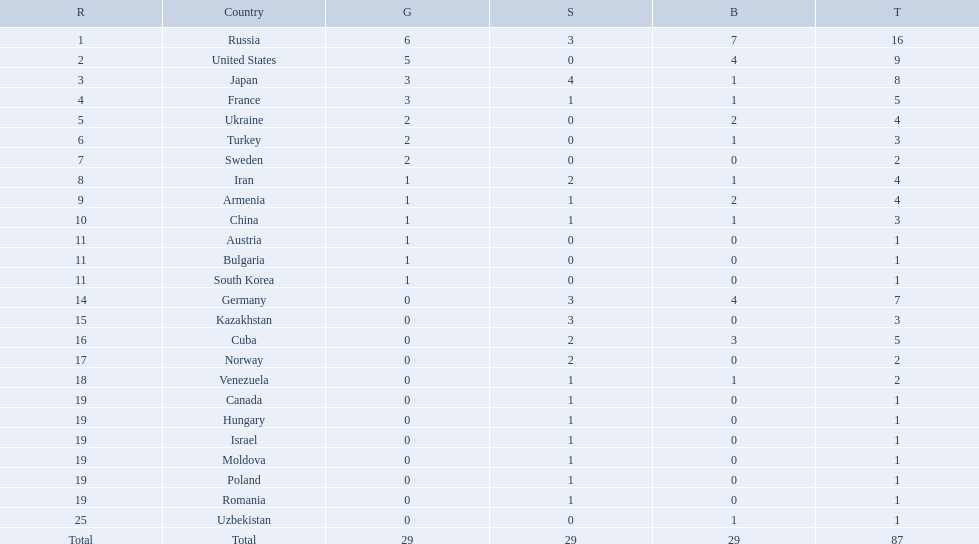What was iran's ranking? 8. What was germany's ranking? 14. Between iran and germany, which was not in the top 10? Germany. What were the nations that participated in the 1995 world wrestling championships? Russia, United States, Japan, France, Ukraine, Turkey, Sweden, Iran, Armenia, China, Austria, Bulgaria, South Korea, Germany, Kazakhstan, Cuba, Norway, Venezuela, Canada, Hungary, Israel, Moldova, Poland, Romania, Uzbekistan. How many gold medals did the united states earn in the championship? 5. What amount of medals earner was greater than this value? 6. What country earned these medals? Russia. Which countries competed in the 1995 world wrestling championships? Russia, United States, Japan, France, Ukraine, Turkey, Sweden, Iran, Armenia, China, Austria, Bulgaria, South Korea, Germany, Kazakhstan, Cuba, Norway, Venezuela, Canada, Hungary, Israel, Moldova, Poland, Romania, Uzbekistan. What country won only one medal? Austria, Bulgaria, South Korea, Canada, Hungary, Israel, Moldova, Poland, Romania, Uzbekistan. Which of these won a bronze medal? Uzbekistan. How many countries competed? Israel. How many total medals did russia win? 16. What country won only 1 medal? Uzbekistan. Which nations only won less then 5 medals? Ukraine, Turkey, Sweden, Iran, Armenia, China, Austria, Bulgaria, South Korea, Germany, Kazakhstan, Norway, Venezuela, Canada, Hungary, Israel, Moldova, Poland, Romania, Uzbekistan. Which of these were not asian nations? Ukraine, Turkey, Sweden, Iran, Armenia, Austria, Bulgaria, Germany, Kazakhstan, Norway, Venezuela, Canada, Hungary, Israel, Moldova, Poland, Romania, Uzbekistan. Which of those did not win any silver medals? Ukraine, Turkey, Sweden, Austria, Bulgaria, Uzbekistan. Which ones of these had only one medal total? Austria, Bulgaria, Uzbekistan. Which of those would be listed first alphabetically? Austria. 